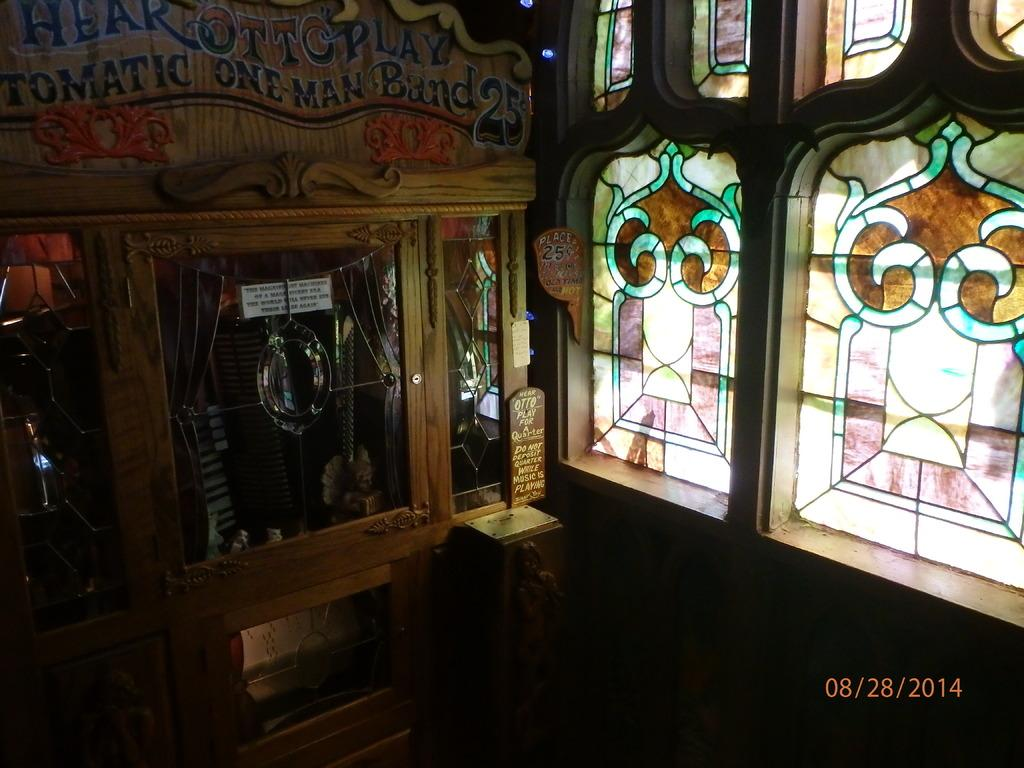What type of furniture is in the image? There is a wooden cupboard in the image. What is placed on the wooden cupboard? There are glasses on the cupboard. What can be seen on the right side of the image? There are windows on the right side of the image. Can you describe the windows in the image? There is a design on the windows. What type of dinner is being served in the image? There is no dinner present in the image; it only features a wooden cupboard, glasses, and windows with a design. 